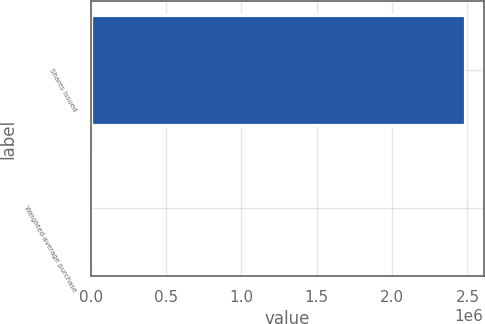Convert chart to OTSL. <chart><loc_0><loc_0><loc_500><loc_500><bar_chart><fcel>Shares issued<fcel>Weighted-average purchase<nl><fcel>2.48228e+06<fcel>9.72<nl></chart> 